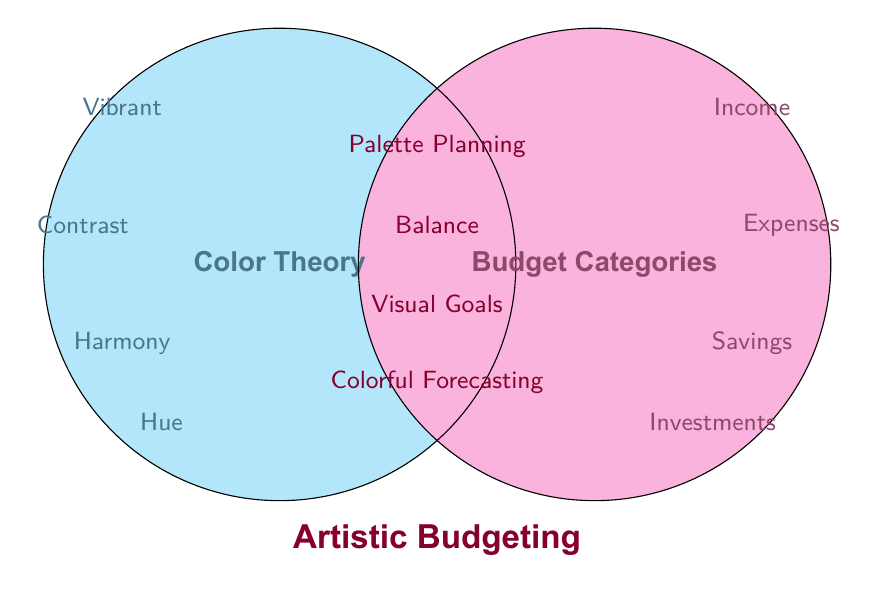What are the categories unique to Color Theory? The categories unique to Color Theory are located in the left circle, outside the overlapping area with Budget Categories. These are Vibrant, Contrast, Harmony, Hue, and Saturation.
Answer: Vibrant, Contrast, Harmony, Hue, Saturation What category is shared by both Color Theory and Budget Categories involving planning? From the overlapping region of both circles, the category related to planning is Palette Planning.
Answer: Palette Planning Which categories exist only in Budget Categories and not in Color Theory? The categories unique to Budget Categories are located in the right circle, outside the overlapping zone. These are Income, Expenses, Savings, Investments, and Emergency Fund.
Answer: Income, Expenses, Savings, Investments, Emergency Fund Which category is associated with achieving financial balance and is also relevant to color theory? The overlapping section denotes categories relevant to both Color Theory and Budget Categories. The shared category related to achieving balance is labeled Balance.
Answer: Balance Identify a category that addresses savings in Budget Categories and a category related to harmony in Color Theory. For Budget Categories, the category addressing savings is Savings. In Color Theory, the category related to harmony is Harmony.
Answer: Savings, Harmony How many categories are common between both Color Theory and Budget Categories? The overlapping area of the Venn Diagram shows the common categories. They are Palette Planning, Balance, Visual Goals, Colorful Forecasting, Tone Management, and Artistic Budgeting, making a total of six.
Answer: Six Which areas correspond to both investments in Budget Categories and color forecasting in Color Theory? Investments in Budget Categories relate to Colorful Forecasting in Color Theory, found in the overlapping region.
Answer: Colorful Forecasting What is the total number of unique categories in the diagram? Add the unique categories from Color Theory, the unique categories from Budget Categories, and the shared categories. This sum includes 5 (Color Theory) + 5 (Budget Categories) + 6 (Shared), totaling 16 categories.
Answer: 16 